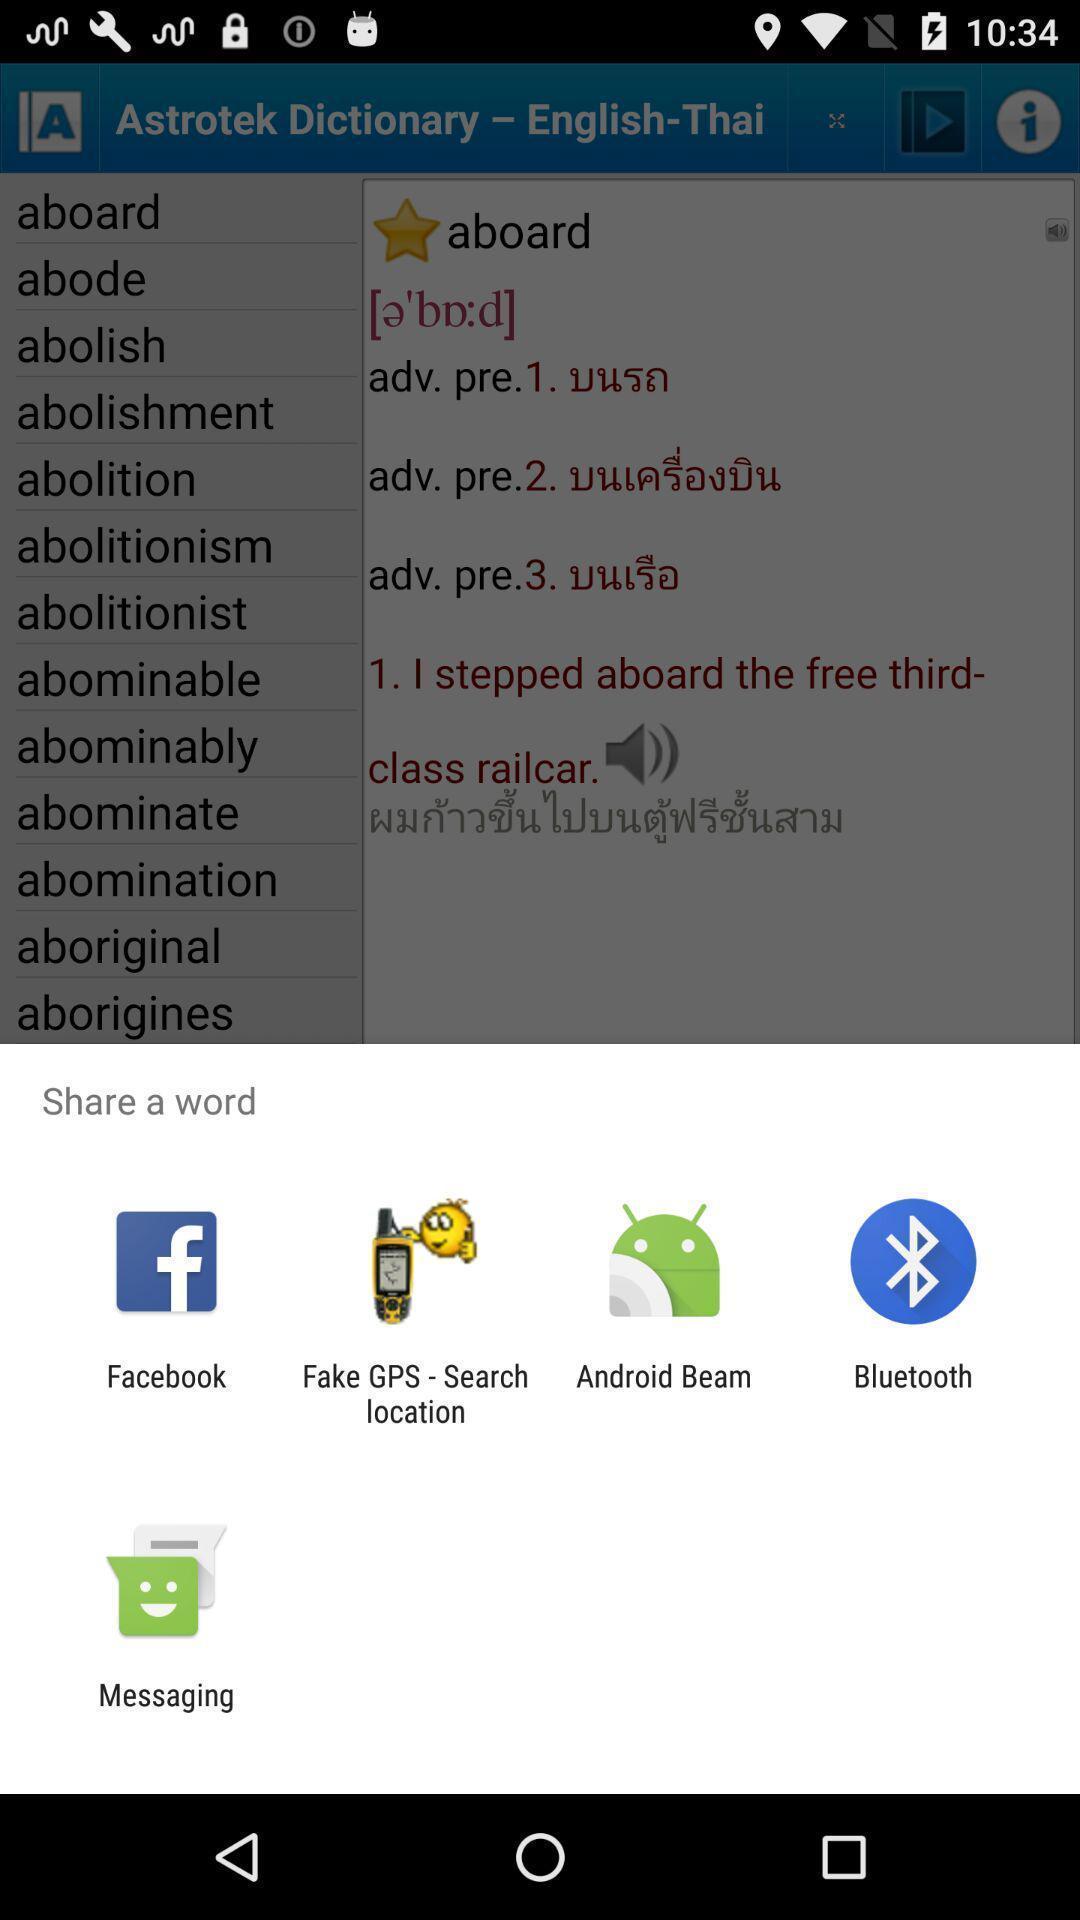What details can you identify in this image? Pop-up showing various options to share the word. 